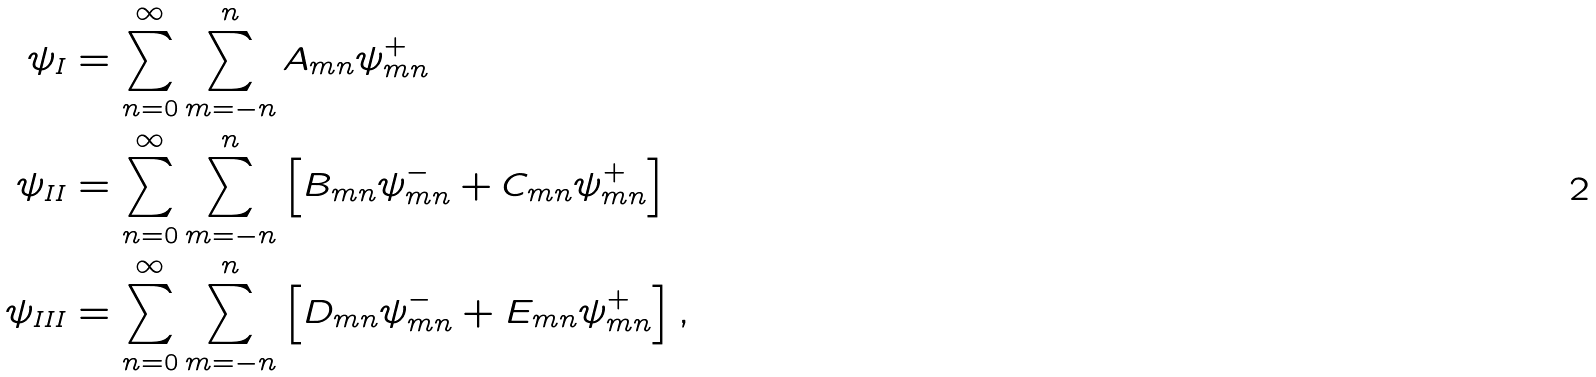<formula> <loc_0><loc_0><loc_500><loc_500>\psi _ { I } & = \sum _ { n = 0 } ^ { \infty } \sum _ { m = - n } ^ { n } A _ { m n } \psi _ { m n } ^ { + } \\ \psi _ { I I } & = \sum _ { n = 0 } ^ { \infty } \sum _ { m = - n } ^ { n } \left [ B _ { m n } \psi _ { m n } ^ { - } + C _ { m n } \psi _ { m n } ^ { + } \right ] \\ \psi _ { I I I } & = \sum _ { n = 0 } ^ { \infty } \sum _ { m = - n } ^ { n } \left [ D _ { m n } \psi _ { m n } ^ { - } + E _ { m n } \psi _ { m n } ^ { + } \right ] ,</formula> 